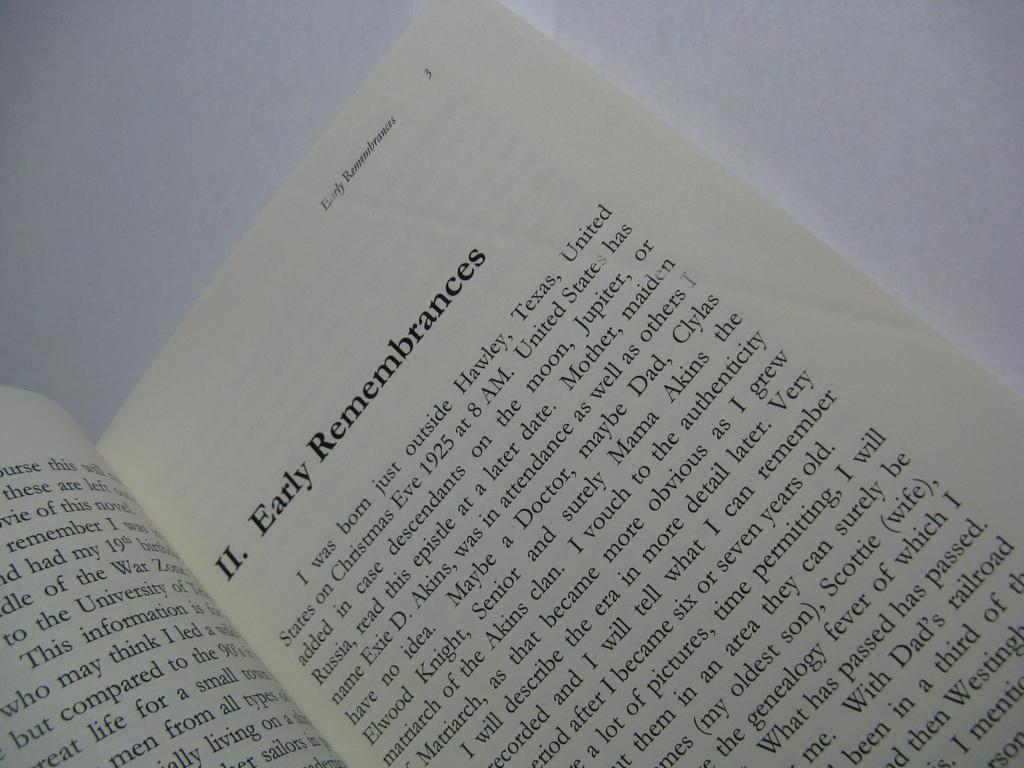Provide a one-sentence caption for the provided image. A book is open to II. Early Remembrences. 